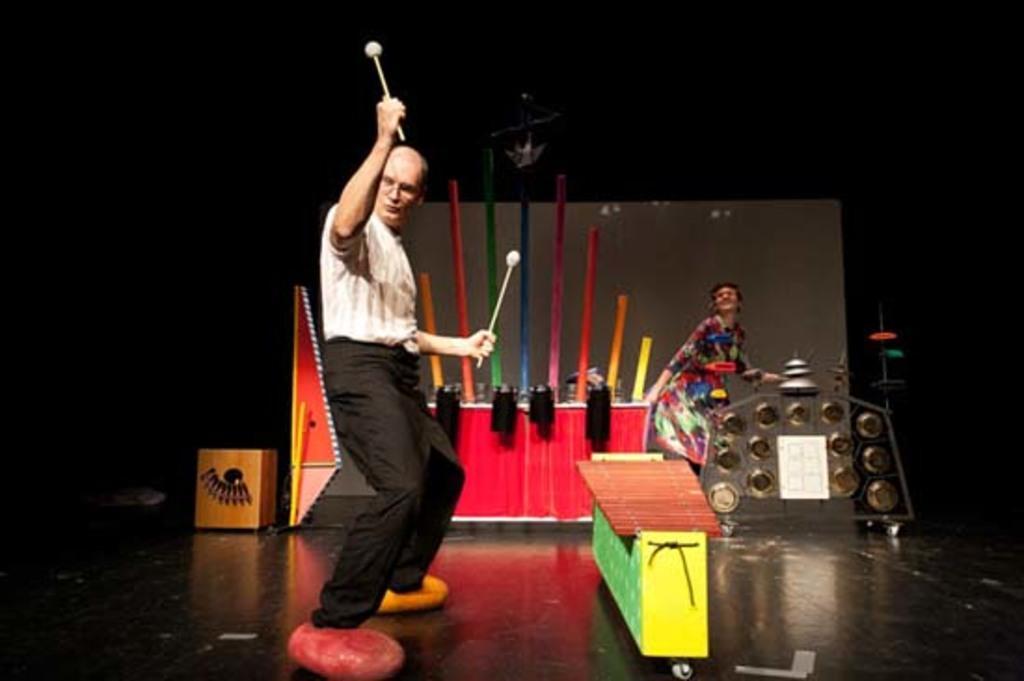In one or two sentences, can you explain what this image depicts? In this image there are artists performing on the stage and there are objects which are yellow, red and pink and blue in colour and there is a curtain which is white in colour. 